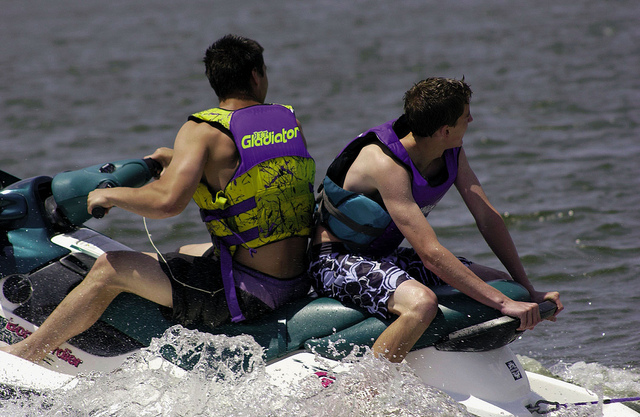Read all the text in this image. Gladiator 